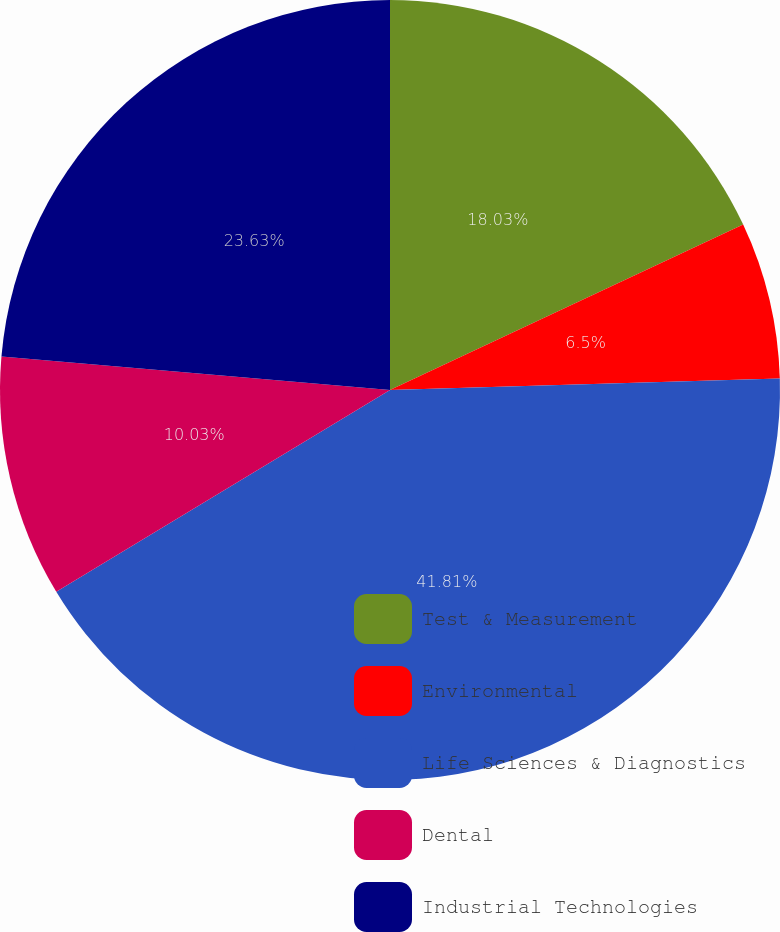<chart> <loc_0><loc_0><loc_500><loc_500><pie_chart><fcel>Test & Measurement<fcel>Environmental<fcel>Life Sciences & Diagnostics<fcel>Dental<fcel>Industrial Technologies<nl><fcel>18.03%<fcel>6.5%<fcel>41.82%<fcel>10.03%<fcel>23.63%<nl></chart> 